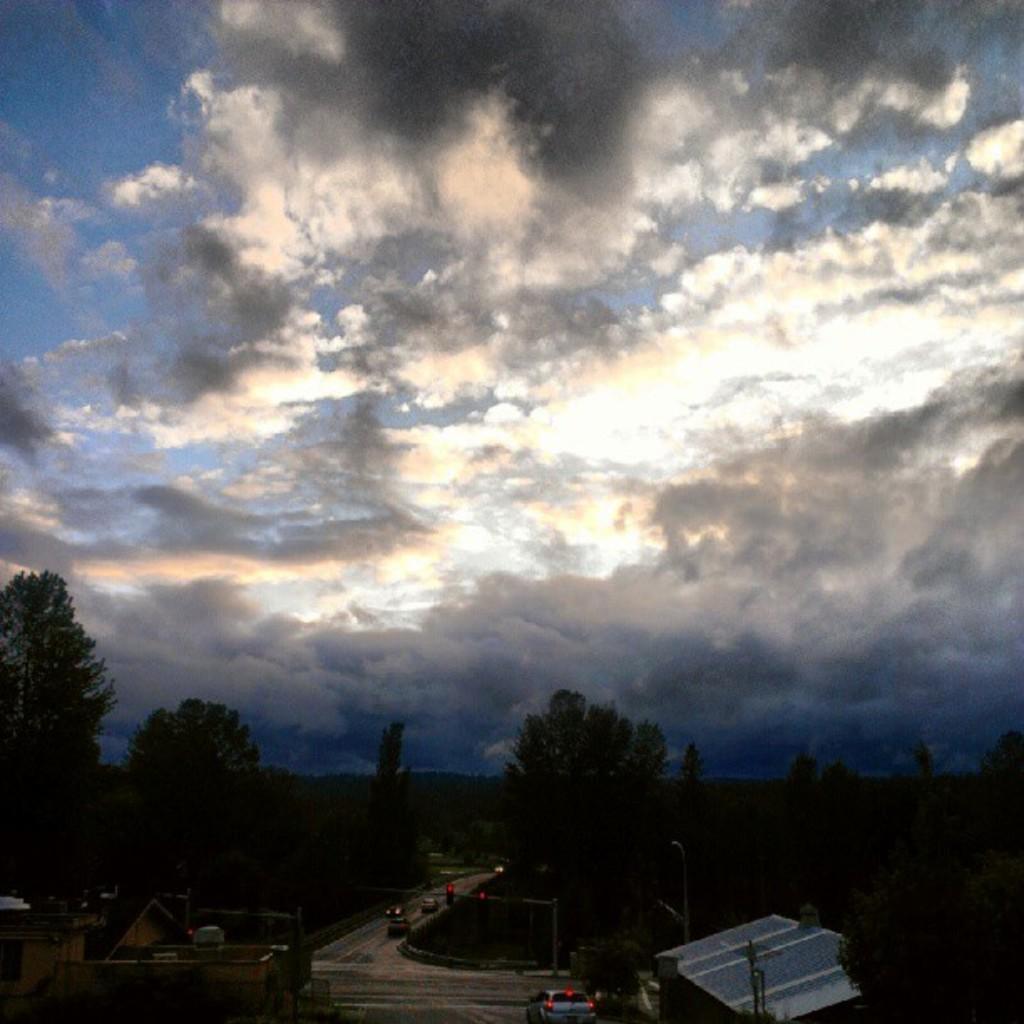Can you describe this image briefly? In this image, we can see a cloudy sky. At the bottom, there are so many trees, houses, roads, vehicles, poles. 